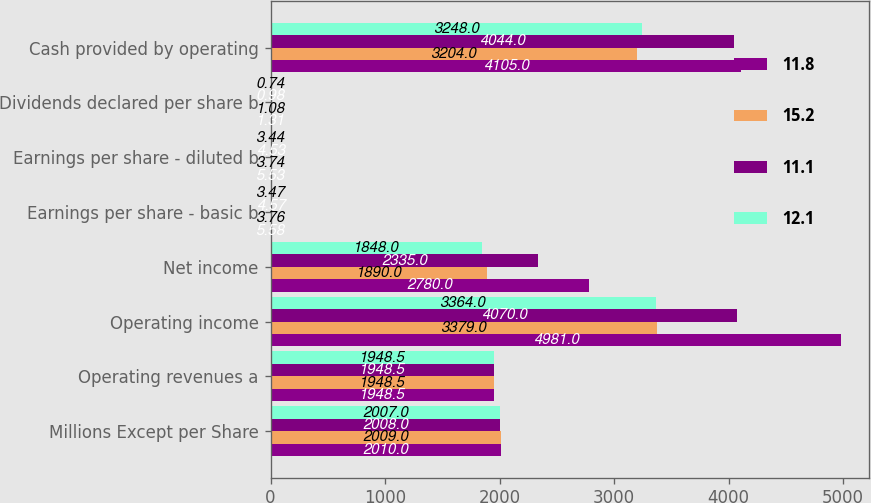<chart> <loc_0><loc_0><loc_500><loc_500><stacked_bar_chart><ecel><fcel>Millions Except per Share<fcel>Operating revenues a<fcel>Operating income<fcel>Net income<fcel>Earnings per share - basic b<fcel>Earnings per share - diluted b<fcel>Dividends declared per share b<fcel>Cash provided by operating<nl><fcel>11.8<fcel>2010<fcel>1948.5<fcel>4981<fcel>2780<fcel>5.58<fcel>5.53<fcel>1.31<fcel>4105<nl><fcel>15.2<fcel>2009<fcel>1948.5<fcel>3379<fcel>1890<fcel>3.76<fcel>3.74<fcel>1.08<fcel>3204<nl><fcel>11.1<fcel>2008<fcel>1948.5<fcel>4070<fcel>2335<fcel>4.57<fcel>4.53<fcel>0.98<fcel>4044<nl><fcel>12.1<fcel>2007<fcel>1948.5<fcel>3364<fcel>1848<fcel>3.47<fcel>3.44<fcel>0.74<fcel>3248<nl></chart> 